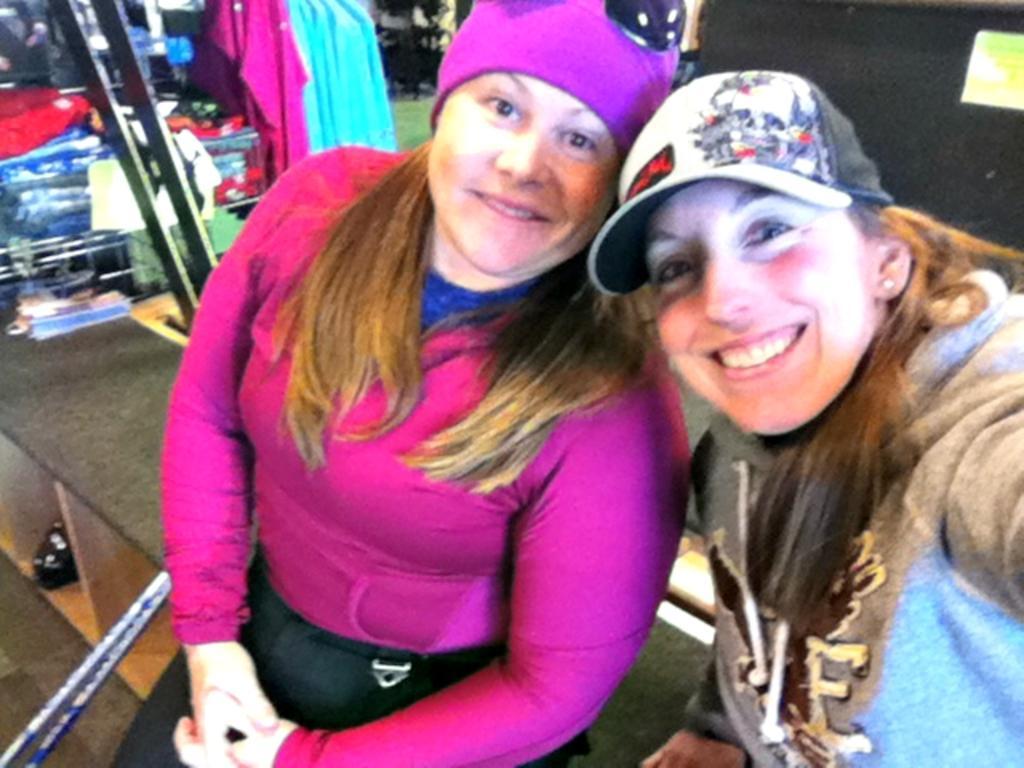Could you give a brief overview of what you see in this image? In this picture we can see there are two women sitting on an object. Behind the women there are clothes and some objects. 